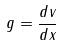Convert formula to latex. <formula><loc_0><loc_0><loc_500><loc_500>g = \frac { d v } { d x }</formula> 